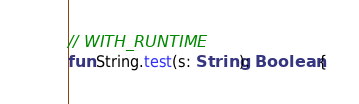Convert code to text. <code><loc_0><loc_0><loc_500><loc_500><_Kotlin_>// WITH_RUNTIME
fun String.test(s: String): Boolean {</code> 